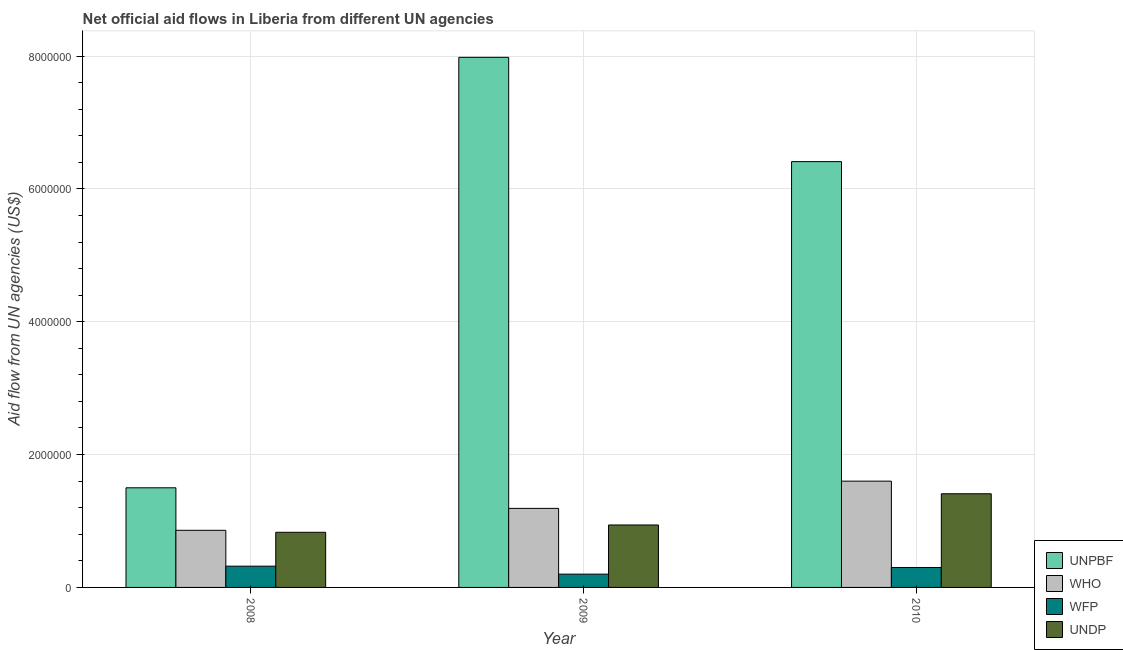How many groups of bars are there?
Your answer should be compact. 3. Are the number of bars per tick equal to the number of legend labels?
Provide a succinct answer. Yes. Are the number of bars on each tick of the X-axis equal?
Your answer should be compact. Yes. How many bars are there on the 2nd tick from the left?
Provide a succinct answer. 4. What is the label of the 3rd group of bars from the left?
Your response must be concise. 2010. In how many cases, is the number of bars for a given year not equal to the number of legend labels?
Offer a terse response. 0. What is the amount of aid given by undp in 2009?
Your answer should be compact. 9.40e+05. Across all years, what is the maximum amount of aid given by who?
Your answer should be very brief. 1.60e+06. Across all years, what is the minimum amount of aid given by wfp?
Offer a very short reply. 2.00e+05. In which year was the amount of aid given by unpbf maximum?
Your answer should be compact. 2009. What is the total amount of aid given by unpbf in the graph?
Give a very brief answer. 1.59e+07. What is the difference between the amount of aid given by who in 2008 and that in 2010?
Provide a short and direct response. -7.40e+05. What is the difference between the amount of aid given by wfp in 2008 and the amount of aid given by who in 2010?
Your answer should be very brief. 2.00e+04. What is the average amount of aid given by who per year?
Offer a terse response. 1.22e+06. In the year 2008, what is the difference between the amount of aid given by unpbf and amount of aid given by who?
Ensure brevity in your answer.  0. What is the ratio of the amount of aid given by undp in 2008 to that in 2010?
Make the answer very short. 0.59. Is the amount of aid given by wfp in 2008 less than that in 2009?
Make the answer very short. No. Is the difference between the amount of aid given by who in 2009 and 2010 greater than the difference between the amount of aid given by wfp in 2009 and 2010?
Make the answer very short. No. What is the difference between the highest and the lowest amount of aid given by who?
Offer a terse response. 7.40e+05. In how many years, is the amount of aid given by unpbf greater than the average amount of aid given by unpbf taken over all years?
Your answer should be very brief. 2. Is the sum of the amount of aid given by who in 2008 and 2009 greater than the maximum amount of aid given by unpbf across all years?
Provide a succinct answer. Yes. What does the 4th bar from the left in 2010 represents?
Provide a succinct answer. UNDP. What does the 4th bar from the right in 2010 represents?
Give a very brief answer. UNPBF. Is it the case that in every year, the sum of the amount of aid given by unpbf and amount of aid given by who is greater than the amount of aid given by wfp?
Make the answer very short. Yes. Are all the bars in the graph horizontal?
Keep it short and to the point. No. Does the graph contain any zero values?
Keep it short and to the point. No. Where does the legend appear in the graph?
Provide a succinct answer. Bottom right. How are the legend labels stacked?
Your response must be concise. Vertical. What is the title of the graph?
Offer a very short reply. Net official aid flows in Liberia from different UN agencies. What is the label or title of the X-axis?
Make the answer very short. Year. What is the label or title of the Y-axis?
Provide a succinct answer. Aid flow from UN agencies (US$). What is the Aid flow from UN agencies (US$) of UNPBF in 2008?
Provide a succinct answer. 1.50e+06. What is the Aid flow from UN agencies (US$) of WHO in 2008?
Provide a short and direct response. 8.60e+05. What is the Aid flow from UN agencies (US$) of UNDP in 2008?
Ensure brevity in your answer.  8.30e+05. What is the Aid flow from UN agencies (US$) of UNPBF in 2009?
Ensure brevity in your answer.  7.98e+06. What is the Aid flow from UN agencies (US$) in WHO in 2009?
Your response must be concise. 1.19e+06. What is the Aid flow from UN agencies (US$) in WFP in 2009?
Offer a very short reply. 2.00e+05. What is the Aid flow from UN agencies (US$) in UNDP in 2009?
Offer a terse response. 9.40e+05. What is the Aid flow from UN agencies (US$) of UNPBF in 2010?
Offer a terse response. 6.41e+06. What is the Aid flow from UN agencies (US$) in WHO in 2010?
Your answer should be compact. 1.60e+06. What is the Aid flow from UN agencies (US$) in UNDP in 2010?
Make the answer very short. 1.41e+06. Across all years, what is the maximum Aid flow from UN agencies (US$) of UNPBF?
Your answer should be compact. 7.98e+06. Across all years, what is the maximum Aid flow from UN agencies (US$) in WHO?
Offer a very short reply. 1.60e+06. Across all years, what is the maximum Aid flow from UN agencies (US$) in WFP?
Your answer should be very brief. 3.20e+05. Across all years, what is the maximum Aid flow from UN agencies (US$) in UNDP?
Keep it short and to the point. 1.41e+06. Across all years, what is the minimum Aid flow from UN agencies (US$) of UNPBF?
Give a very brief answer. 1.50e+06. Across all years, what is the minimum Aid flow from UN agencies (US$) in WHO?
Provide a succinct answer. 8.60e+05. Across all years, what is the minimum Aid flow from UN agencies (US$) of WFP?
Your response must be concise. 2.00e+05. Across all years, what is the minimum Aid flow from UN agencies (US$) of UNDP?
Keep it short and to the point. 8.30e+05. What is the total Aid flow from UN agencies (US$) in UNPBF in the graph?
Give a very brief answer. 1.59e+07. What is the total Aid flow from UN agencies (US$) in WHO in the graph?
Give a very brief answer. 3.65e+06. What is the total Aid flow from UN agencies (US$) of WFP in the graph?
Provide a succinct answer. 8.20e+05. What is the total Aid flow from UN agencies (US$) in UNDP in the graph?
Give a very brief answer. 3.18e+06. What is the difference between the Aid flow from UN agencies (US$) of UNPBF in 2008 and that in 2009?
Give a very brief answer. -6.48e+06. What is the difference between the Aid flow from UN agencies (US$) in WHO in 2008 and that in 2009?
Keep it short and to the point. -3.30e+05. What is the difference between the Aid flow from UN agencies (US$) of WFP in 2008 and that in 2009?
Provide a short and direct response. 1.20e+05. What is the difference between the Aid flow from UN agencies (US$) of UNDP in 2008 and that in 2009?
Your response must be concise. -1.10e+05. What is the difference between the Aid flow from UN agencies (US$) of UNPBF in 2008 and that in 2010?
Provide a short and direct response. -4.91e+06. What is the difference between the Aid flow from UN agencies (US$) in WHO in 2008 and that in 2010?
Your answer should be very brief. -7.40e+05. What is the difference between the Aid flow from UN agencies (US$) in UNDP in 2008 and that in 2010?
Your answer should be very brief. -5.80e+05. What is the difference between the Aid flow from UN agencies (US$) of UNPBF in 2009 and that in 2010?
Provide a short and direct response. 1.57e+06. What is the difference between the Aid flow from UN agencies (US$) in WHO in 2009 and that in 2010?
Provide a short and direct response. -4.10e+05. What is the difference between the Aid flow from UN agencies (US$) in UNDP in 2009 and that in 2010?
Offer a terse response. -4.70e+05. What is the difference between the Aid flow from UN agencies (US$) in UNPBF in 2008 and the Aid flow from UN agencies (US$) in WFP in 2009?
Offer a very short reply. 1.30e+06. What is the difference between the Aid flow from UN agencies (US$) in UNPBF in 2008 and the Aid flow from UN agencies (US$) in UNDP in 2009?
Provide a succinct answer. 5.60e+05. What is the difference between the Aid flow from UN agencies (US$) in WHO in 2008 and the Aid flow from UN agencies (US$) in WFP in 2009?
Your response must be concise. 6.60e+05. What is the difference between the Aid flow from UN agencies (US$) of WHO in 2008 and the Aid flow from UN agencies (US$) of UNDP in 2009?
Ensure brevity in your answer.  -8.00e+04. What is the difference between the Aid flow from UN agencies (US$) of WFP in 2008 and the Aid flow from UN agencies (US$) of UNDP in 2009?
Make the answer very short. -6.20e+05. What is the difference between the Aid flow from UN agencies (US$) of UNPBF in 2008 and the Aid flow from UN agencies (US$) of WFP in 2010?
Ensure brevity in your answer.  1.20e+06. What is the difference between the Aid flow from UN agencies (US$) in UNPBF in 2008 and the Aid flow from UN agencies (US$) in UNDP in 2010?
Make the answer very short. 9.00e+04. What is the difference between the Aid flow from UN agencies (US$) of WHO in 2008 and the Aid flow from UN agencies (US$) of WFP in 2010?
Your answer should be very brief. 5.60e+05. What is the difference between the Aid flow from UN agencies (US$) in WHO in 2008 and the Aid flow from UN agencies (US$) in UNDP in 2010?
Ensure brevity in your answer.  -5.50e+05. What is the difference between the Aid flow from UN agencies (US$) of WFP in 2008 and the Aid flow from UN agencies (US$) of UNDP in 2010?
Offer a very short reply. -1.09e+06. What is the difference between the Aid flow from UN agencies (US$) of UNPBF in 2009 and the Aid flow from UN agencies (US$) of WHO in 2010?
Ensure brevity in your answer.  6.38e+06. What is the difference between the Aid flow from UN agencies (US$) of UNPBF in 2009 and the Aid flow from UN agencies (US$) of WFP in 2010?
Give a very brief answer. 7.68e+06. What is the difference between the Aid flow from UN agencies (US$) in UNPBF in 2009 and the Aid flow from UN agencies (US$) in UNDP in 2010?
Provide a short and direct response. 6.57e+06. What is the difference between the Aid flow from UN agencies (US$) in WHO in 2009 and the Aid flow from UN agencies (US$) in WFP in 2010?
Give a very brief answer. 8.90e+05. What is the difference between the Aid flow from UN agencies (US$) of WFP in 2009 and the Aid flow from UN agencies (US$) of UNDP in 2010?
Your response must be concise. -1.21e+06. What is the average Aid flow from UN agencies (US$) in UNPBF per year?
Your answer should be very brief. 5.30e+06. What is the average Aid flow from UN agencies (US$) of WHO per year?
Provide a succinct answer. 1.22e+06. What is the average Aid flow from UN agencies (US$) of WFP per year?
Your answer should be very brief. 2.73e+05. What is the average Aid flow from UN agencies (US$) in UNDP per year?
Provide a succinct answer. 1.06e+06. In the year 2008, what is the difference between the Aid flow from UN agencies (US$) of UNPBF and Aid flow from UN agencies (US$) of WHO?
Ensure brevity in your answer.  6.40e+05. In the year 2008, what is the difference between the Aid flow from UN agencies (US$) in UNPBF and Aid flow from UN agencies (US$) in WFP?
Ensure brevity in your answer.  1.18e+06. In the year 2008, what is the difference between the Aid flow from UN agencies (US$) in UNPBF and Aid flow from UN agencies (US$) in UNDP?
Your answer should be very brief. 6.70e+05. In the year 2008, what is the difference between the Aid flow from UN agencies (US$) in WHO and Aid flow from UN agencies (US$) in WFP?
Give a very brief answer. 5.40e+05. In the year 2008, what is the difference between the Aid flow from UN agencies (US$) in WHO and Aid flow from UN agencies (US$) in UNDP?
Provide a short and direct response. 3.00e+04. In the year 2008, what is the difference between the Aid flow from UN agencies (US$) in WFP and Aid flow from UN agencies (US$) in UNDP?
Provide a short and direct response. -5.10e+05. In the year 2009, what is the difference between the Aid flow from UN agencies (US$) in UNPBF and Aid flow from UN agencies (US$) in WHO?
Offer a very short reply. 6.79e+06. In the year 2009, what is the difference between the Aid flow from UN agencies (US$) of UNPBF and Aid flow from UN agencies (US$) of WFP?
Your answer should be compact. 7.78e+06. In the year 2009, what is the difference between the Aid flow from UN agencies (US$) of UNPBF and Aid flow from UN agencies (US$) of UNDP?
Offer a very short reply. 7.04e+06. In the year 2009, what is the difference between the Aid flow from UN agencies (US$) of WHO and Aid flow from UN agencies (US$) of WFP?
Ensure brevity in your answer.  9.90e+05. In the year 2009, what is the difference between the Aid flow from UN agencies (US$) of WFP and Aid flow from UN agencies (US$) of UNDP?
Keep it short and to the point. -7.40e+05. In the year 2010, what is the difference between the Aid flow from UN agencies (US$) in UNPBF and Aid flow from UN agencies (US$) in WHO?
Provide a succinct answer. 4.81e+06. In the year 2010, what is the difference between the Aid flow from UN agencies (US$) in UNPBF and Aid flow from UN agencies (US$) in WFP?
Provide a short and direct response. 6.11e+06. In the year 2010, what is the difference between the Aid flow from UN agencies (US$) of WHO and Aid flow from UN agencies (US$) of WFP?
Your answer should be very brief. 1.30e+06. In the year 2010, what is the difference between the Aid flow from UN agencies (US$) in WHO and Aid flow from UN agencies (US$) in UNDP?
Keep it short and to the point. 1.90e+05. In the year 2010, what is the difference between the Aid flow from UN agencies (US$) in WFP and Aid flow from UN agencies (US$) in UNDP?
Ensure brevity in your answer.  -1.11e+06. What is the ratio of the Aid flow from UN agencies (US$) of UNPBF in 2008 to that in 2009?
Provide a succinct answer. 0.19. What is the ratio of the Aid flow from UN agencies (US$) of WHO in 2008 to that in 2009?
Give a very brief answer. 0.72. What is the ratio of the Aid flow from UN agencies (US$) in UNDP in 2008 to that in 2009?
Your response must be concise. 0.88. What is the ratio of the Aid flow from UN agencies (US$) of UNPBF in 2008 to that in 2010?
Your answer should be compact. 0.23. What is the ratio of the Aid flow from UN agencies (US$) of WHO in 2008 to that in 2010?
Provide a succinct answer. 0.54. What is the ratio of the Aid flow from UN agencies (US$) of WFP in 2008 to that in 2010?
Provide a short and direct response. 1.07. What is the ratio of the Aid flow from UN agencies (US$) of UNDP in 2008 to that in 2010?
Offer a very short reply. 0.59. What is the ratio of the Aid flow from UN agencies (US$) of UNPBF in 2009 to that in 2010?
Your response must be concise. 1.24. What is the ratio of the Aid flow from UN agencies (US$) of WHO in 2009 to that in 2010?
Your answer should be very brief. 0.74. What is the ratio of the Aid flow from UN agencies (US$) in WFP in 2009 to that in 2010?
Ensure brevity in your answer.  0.67. What is the ratio of the Aid flow from UN agencies (US$) in UNDP in 2009 to that in 2010?
Keep it short and to the point. 0.67. What is the difference between the highest and the second highest Aid flow from UN agencies (US$) of UNPBF?
Give a very brief answer. 1.57e+06. What is the difference between the highest and the second highest Aid flow from UN agencies (US$) in WHO?
Offer a terse response. 4.10e+05. What is the difference between the highest and the second highest Aid flow from UN agencies (US$) in WFP?
Ensure brevity in your answer.  2.00e+04. What is the difference between the highest and the second highest Aid flow from UN agencies (US$) in UNDP?
Make the answer very short. 4.70e+05. What is the difference between the highest and the lowest Aid flow from UN agencies (US$) in UNPBF?
Keep it short and to the point. 6.48e+06. What is the difference between the highest and the lowest Aid flow from UN agencies (US$) of WHO?
Your response must be concise. 7.40e+05. What is the difference between the highest and the lowest Aid flow from UN agencies (US$) in UNDP?
Your response must be concise. 5.80e+05. 